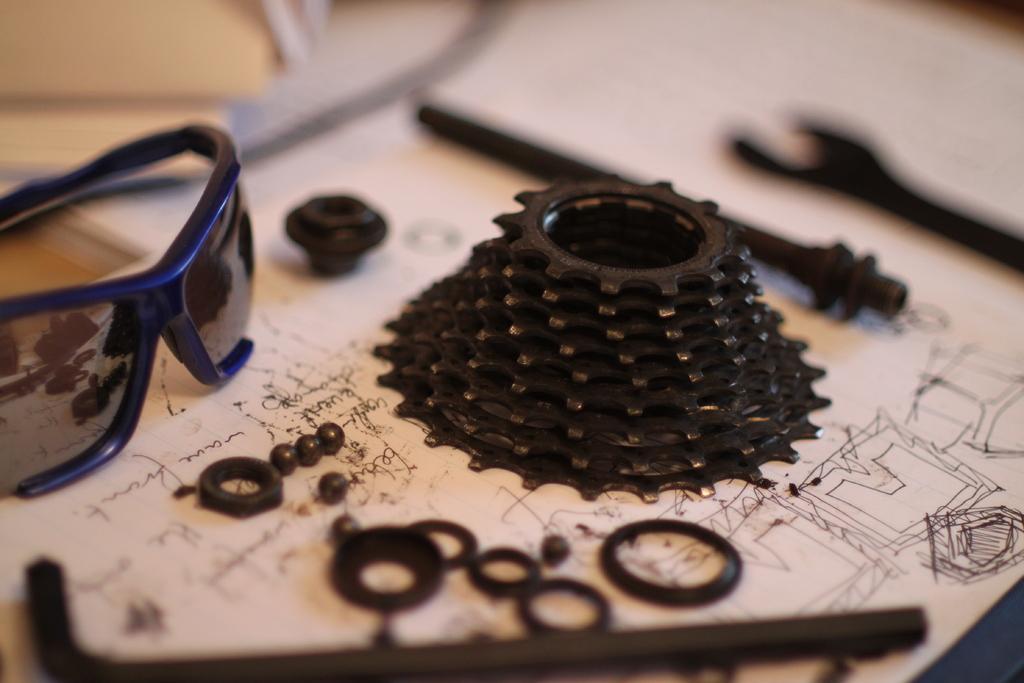Please provide a concise description of this image. In the image in the center, we can see one table. On the table, we can see one paper, glasses and tools. 